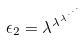<formula> <loc_0><loc_0><loc_500><loc_500>\epsilon _ { 2 } = \lambda ^ { \lambda ^ { \lambda ^ { \cdot ^ { \cdot ^ { \cdot } } } } }</formula> 